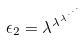<formula> <loc_0><loc_0><loc_500><loc_500>\epsilon _ { 2 } = \lambda ^ { \lambda ^ { \lambda ^ { \cdot ^ { \cdot ^ { \cdot } } } } }</formula> 